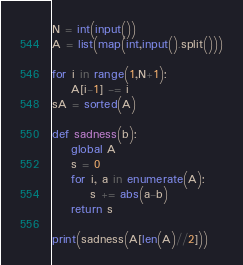<code> <loc_0><loc_0><loc_500><loc_500><_Python_>N = int(input())
A = list(map(int,input().split()))

for i in range(1,N+1):
    A[i-1] -= i
sA = sorted(A)

def sadness(b):
    global A
    s = 0
    for i, a in enumerate(A):
        s += abs(a-b)
    return s

print(sadness(A[len(A)//2]))</code> 